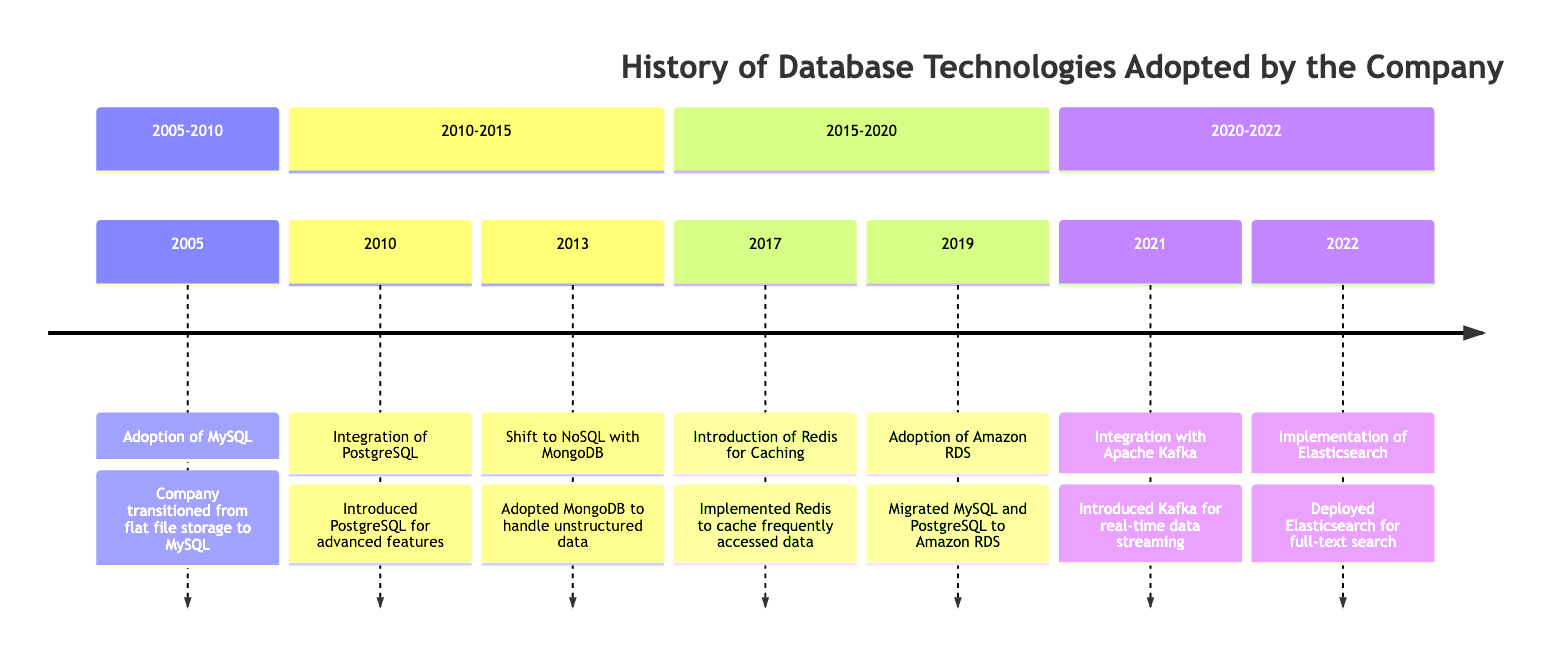What year did the company adopt MySQL? The diagram shows that the event "Adoption of MySQL" occurred in the year 2005, as indicated in the timeline section for that year.
Answer: 2005 How many database technologies were adopted before 2022? By examining the timeline events listed before the year 2022, we find that there are six distinct database technologies mentioned: MySQL, PostgreSQL, MongoDB, Redis, Amazon RDS, and Elasticsearch.
Answer: 6 What technology was integrated in 2010? The diagram indicates that the event listed for the year 2010 is the "Integration of PostgreSQL." This clearly states the technology that was introduced during that year.
Answer: PostgreSQL Which database technology was used for caching in 2017? The timeline shows that in 2017, the "Introduction of Redis for Caching" was implemented, directly stating that Redis is the technology used for caching.
Answer: Redis What is the connection between PostgreSQL and Amazon RDS? PostgreSQL is listed as one of the databases that were migrated to Amazon RDS in the year 2019, indicating a direct integration of PostgreSQL with Amazon RDS for managed services.
Answer: Migrated What improvements did Elasticsearch bring in 2022? The diagram states that "Implementation of Elasticsearch" was carried out in 2022, focusing on full-text search and analytics, which improved the search functionalities within the application.
Answer: Search functionalities What major database shift occurred in 2013? According to the timeline, in 2013, the "Shift to NoSQL with MongoDB" denotes the significant transition to a NoSQL database for handling unstructured data needs.
Answer: NoSQL with MongoDB How many years passed between the adoption of MySQL and the introduction of Redis? To determine the number of years, we subtract the adoption year of MySQL, 2005, from the introduction year of Redis, 2017. This calculation finds that 12 years elapsed between these two events.
Answer: 12 years 